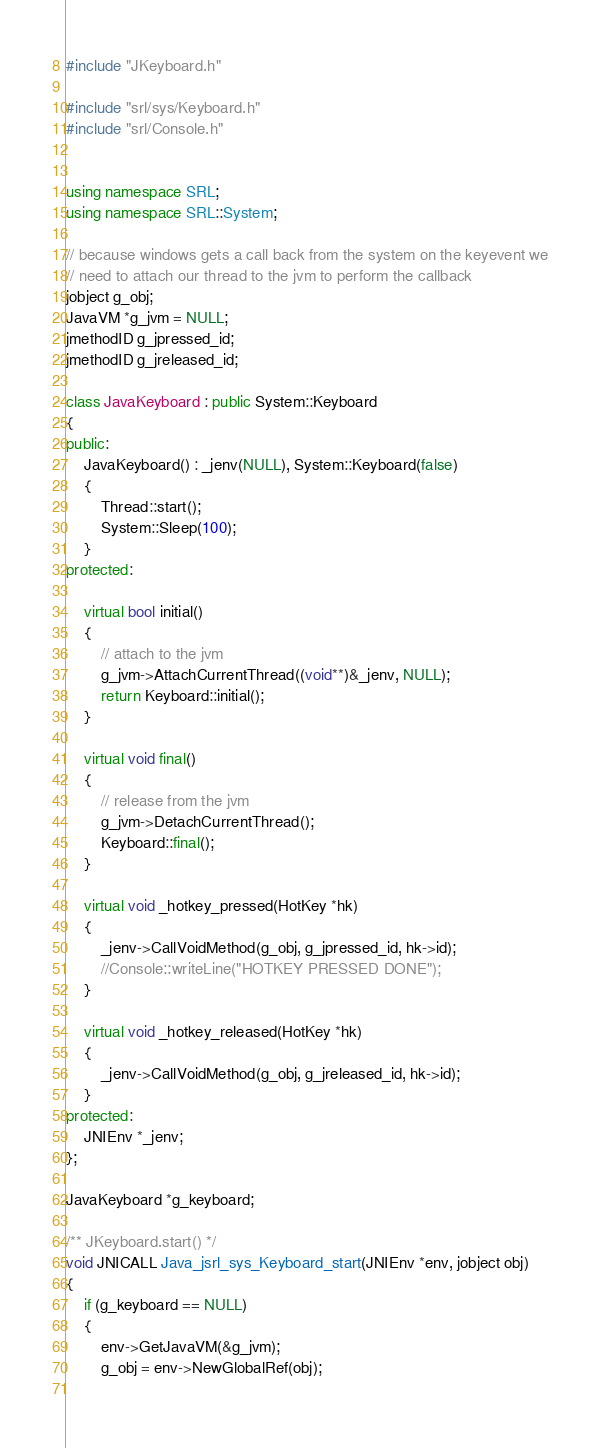<code> <loc_0><loc_0><loc_500><loc_500><_C++_>#include "JKeyboard.h"

#include "srl/sys/Keyboard.h"
#include "srl/Console.h"


using namespace SRL;
using namespace SRL::System;

// because windows gets a call back from the system on the keyevent we
// need to attach our thread to the jvm to perform the callback
jobject g_obj;
JavaVM *g_jvm = NULL;
jmethodID g_jpressed_id;
jmethodID g_jreleased_id;

class JavaKeyboard : public System::Keyboard
{
public:
	JavaKeyboard() : _jenv(NULL), System::Keyboard(false)
    {
		Thread::start();
		System::Sleep(100);
    }
protected:

    virtual bool initial()
    {
        // attach to the jvm
        g_jvm->AttachCurrentThread((void**)&_jenv, NULL);
        return Keyboard::initial();
    }
    
    virtual void final()
    {
        // release from the jvm
        g_jvm->DetachCurrentThread();
        Keyboard::final();
    }
    
    virtual void _hotkey_pressed(HotKey *hk)
    {
        _jenv->CallVoidMethod(g_obj, g_jpressed_id, hk->id);
		//Console::writeLine("HOTKEY PRESSED DONE");
    }
    
    virtual void _hotkey_released(HotKey *hk)
    {
        _jenv->CallVoidMethod(g_obj, g_jreleased_id, hk->id);
    }
protected:
    JNIEnv *_jenv;
};

JavaKeyboard *g_keyboard;

/** JKeyboard.start() */
void JNICALL Java_jsrl_sys_Keyboard_start(JNIEnv *env, jobject obj)
{
	if (g_keyboard == NULL)
	{
	    env->GetJavaVM(&g_jvm);
	    g_obj = env->NewGlobalRef(obj);
	    </code> 